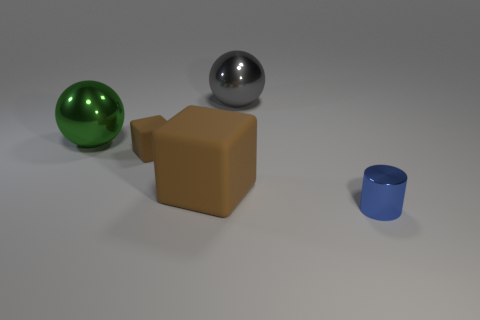How many things are either large green metallic objects or balls on the right side of the large brown matte block?
Offer a very short reply. 2. There is a big metallic object that is behind the large green object; is its shape the same as the big green object?
Give a very brief answer. Yes. There is a object that is in front of the matte thing that is on the right side of the tiny brown object; how many small brown objects are right of it?
Provide a short and direct response. 0. Is there anything else that has the same shape as the small brown matte object?
Offer a very short reply. Yes. How many objects are either small yellow rubber balls or large metallic things?
Give a very brief answer. 2. Do the green metallic thing and the metal thing on the right side of the gray metallic sphere have the same shape?
Provide a short and direct response. No. Are there an equal number of large brown metallic balls and blue metallic things?
Offer a terse response. No. The metal object that is in front of the large green thing has what shape?
Offer a terse response. Cylinder. Does the big brown rubber thing have the same shape as the large green thing?
Offer a very short reply. No. There is a green thing that is the same shape as the large gray metal object; what size is it?
Ensure brevity in your answer.  Large. 